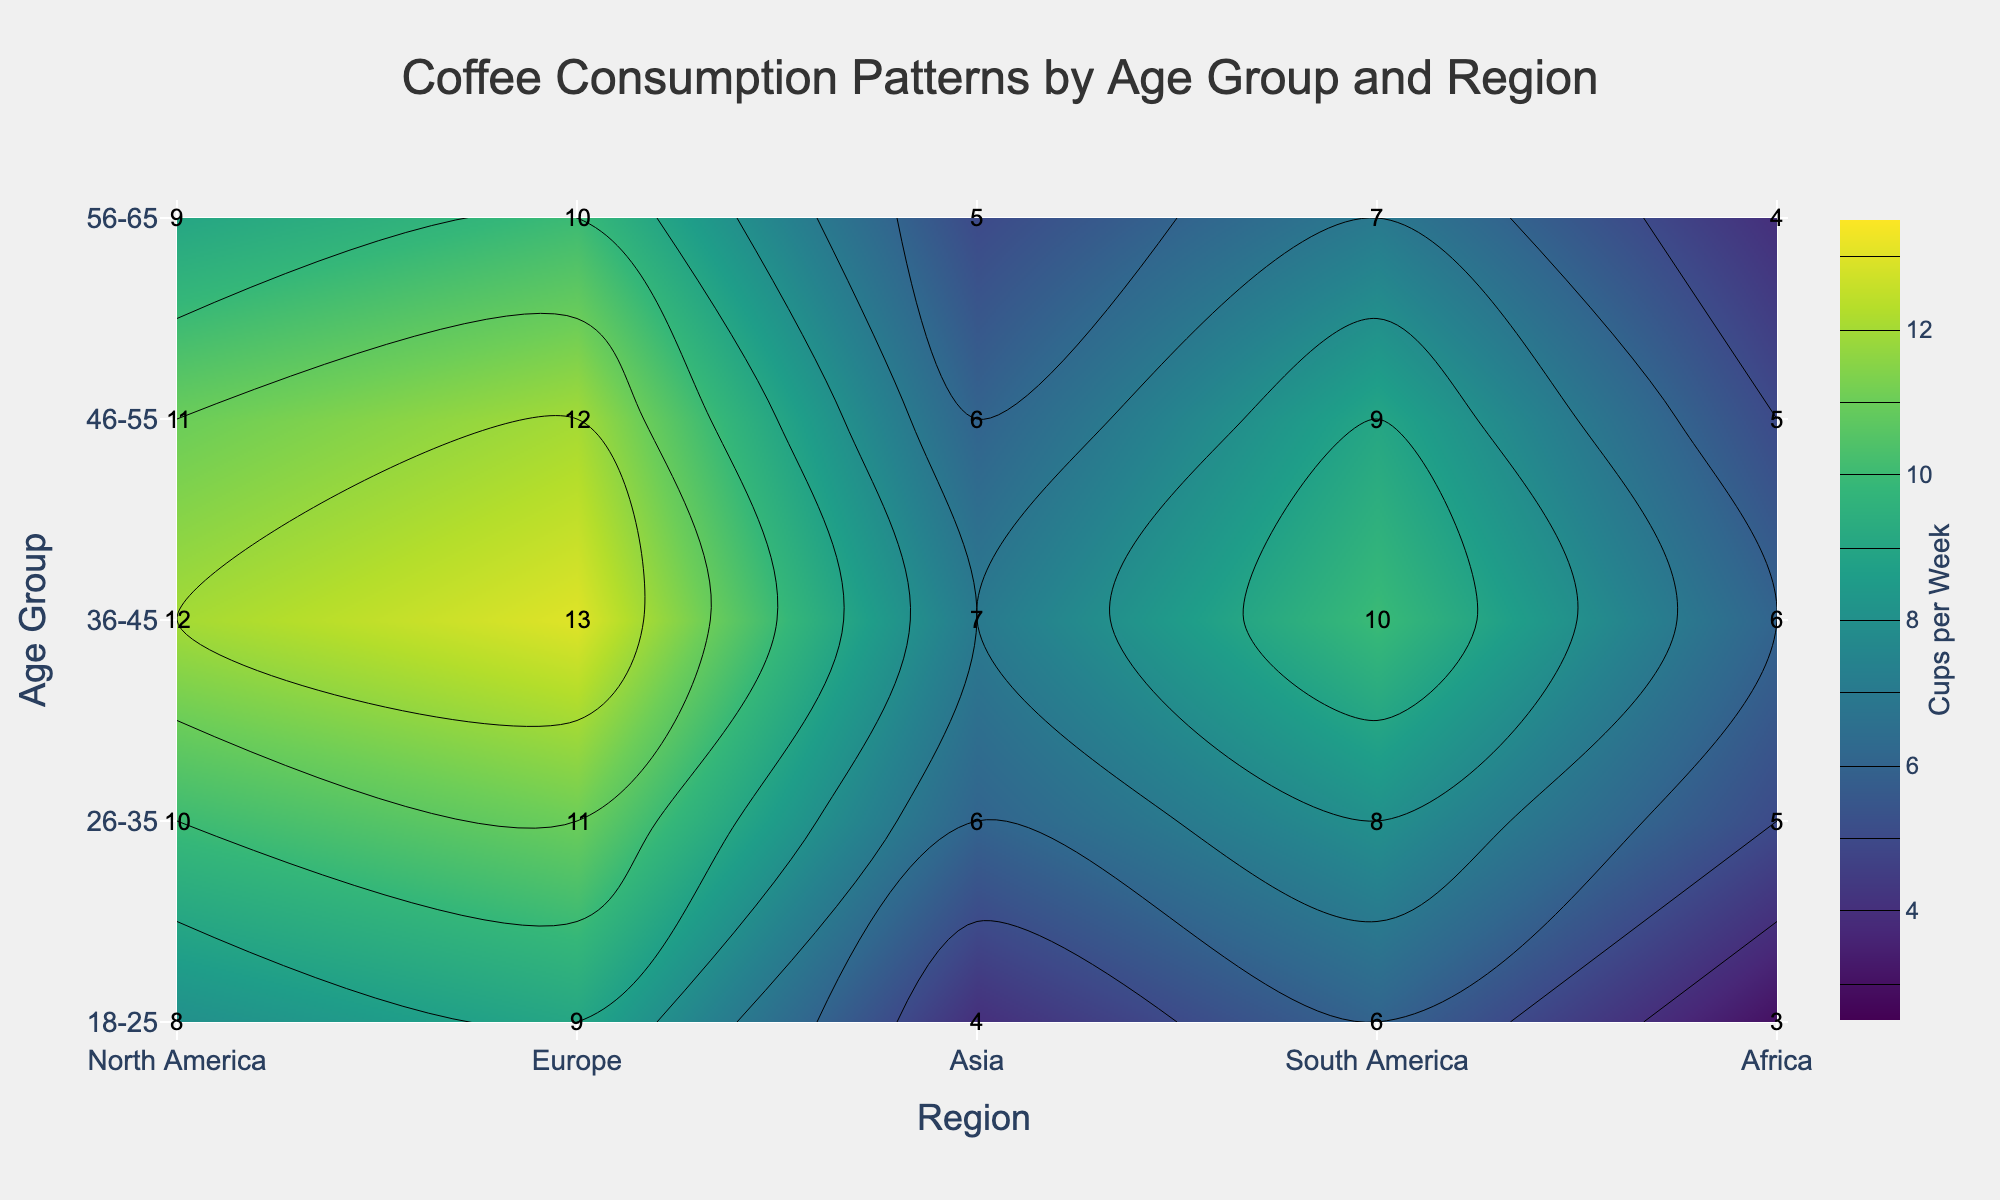What is the title of the plot? The title is a text element located at the top center of the figure, which is plainly noticeable. It provides a summary of the plot's content.
Answer: Coffee Consumption Patterns by Age Group and Region Which age group in North America consumes the most coffee per week? Identify the region "North America" on the x-axis, then look for the highest value in the y-axis corresponding to different age groups.
Answer: 36-45 What are the coffee consumption levels in Europe for the age groups 26-35 and 46-55? Locate the region "Europe" on the x-axis. Then find the consumption values for age group "26-35" and "46-55" on the y-axis.
Answer: 11 and 12 Which region has the lowest coffee consumption for the age group 18-25? Locate the age group "18-25" on the y-axis, then look across the regions on the x-axis to find the lowest value.
Answer: Africa What's the average coffee consumption for the age group 36-45 across all regions? List all consumption values for age group "36-45": (12, 13, 7, 10, 6). Sum these values (12 + 13 + 7 + 10 + 6 = 48) and divide by the number of regions (5).
Answer: 9.6 Which two age groups have the closest coffee consumption values in Asia? Find the values for each age group in Asia (4, 6, 7, 6, 5). Identify which two values are closest numerically.
Answer: 46-55 and 26-35 Is there a trend in coffee consumption as age increases within any single region? Examine one region at a time, moving vertically through the age groups to see if the values consistently increase or decrease.
Answer: Yes, especially in Europe Which age group shows the most variation in coffee consumption across different regions? Compare the range (difference between max and min values) for each age group's consumption values across all regions. The group with the largest range shows the most variation.
Answer: 36-45 What is the highest coffee consumption value shown in the plot and in which regions and age groups does it occur? Visually scan for the highest value in the contour plot. Check the exact regions and age groups.
Answer: 13, Europe, 36-45 What is the difference in coffee consumption between the age groups 26-35 and 56-65 in South America? Find the values for age group "26-35" and "56-65" in South America (8 and 7). Subtract the smaller value from the larger value.
Answer: 1 